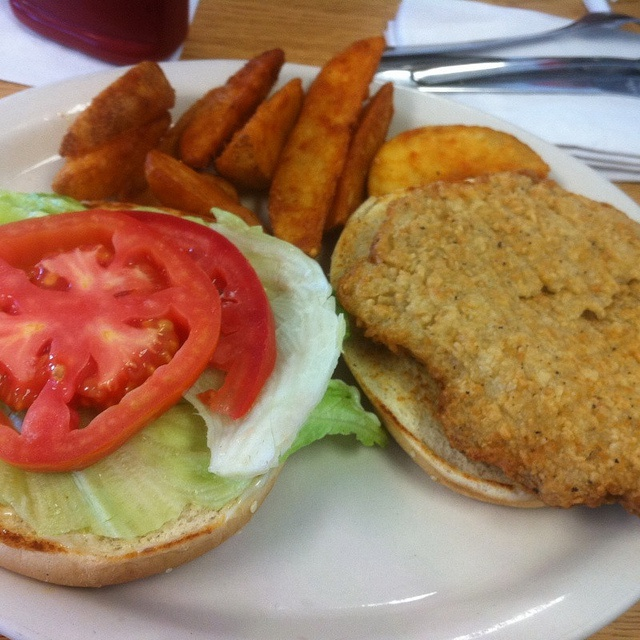Describe the objects in this image and their specific colors. I can see sandwich in lavender, brown, tan, salmon, and red tones, sandwich in lavender, olive, tan, and maroon tones, dining table in lavender, olive, gray, brown, and darkgray tones, spoon in lavender, gray, darkblue, and white tones, and knife in lavender, gray, darkblue, white, and black tones in this image. 